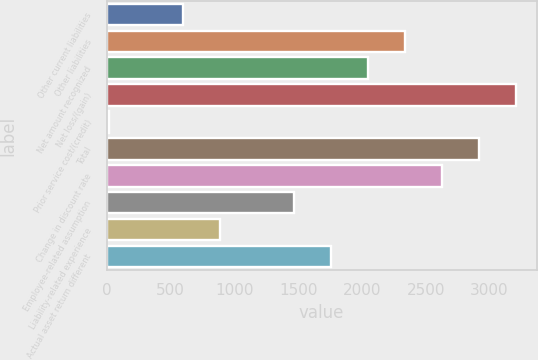Convert chart. <chart><loc_0><loc_0><loc_500><loc_500><bar_chart><fcel>Other current liabilities<fcel>Other liabilities<fcel>Net amount recognized<fcel>Net loss/(gain)<fcel>Prior service cost/(credit)<fcel>Total<fcel>Change in discount rate<fcel>Employee-related assumption<fcel>Liability-related experience<fcel>Actual asset return different<nl><fcel>598<fcel>2338<fcel>2048<fcel>3208<fcel>18<fcel>2918<fcel>2628<fcel>1468<fcel>888<fcel>1758<nl></chart> 